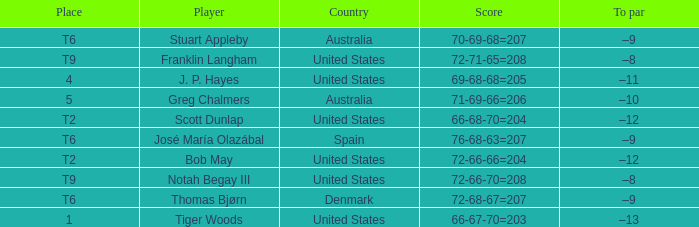What is the place of the player with a 72-71-65=208 score? T9. 